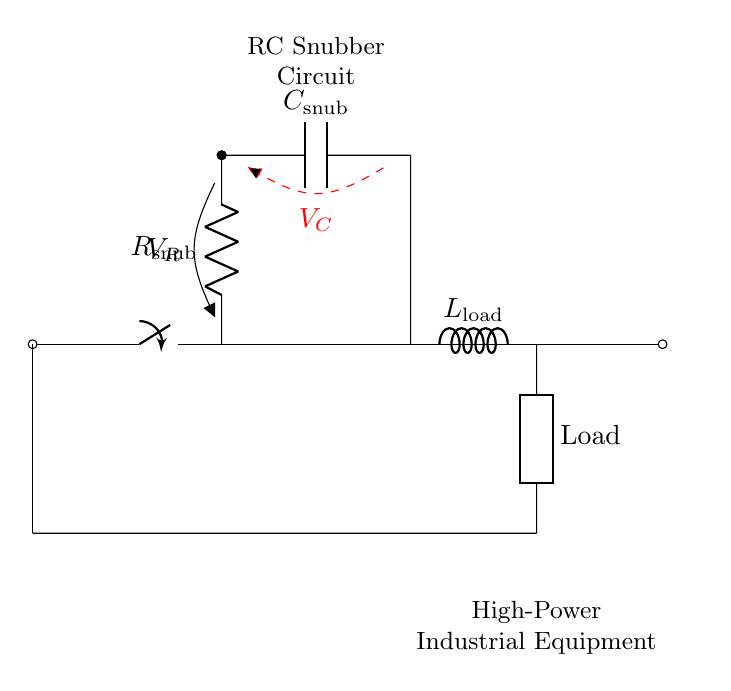What components are present in this circuit? The circuit contains a resistor, capacitor, inductor, switch, and a generic load. These components are visualized in distinct sections of the diagram indicating their roles.
Answer: resistor, capacitor, inductor, switch, load What does the switch control in this circuit? The switch controls the connection between the main power line and the other components of the circuit. When closed, it allows current to flow through the circuit, including the RC snubber.
Answer: power connection What is the purpose of the RC snubber circuit? The RC snubber circuit is designed to protect the high-power equipment from voltage spikes and transients by providing a controlled path for excess energy. This reduces the risk of damage to sensitive components.
Answer: voltage spike protection What is the voltage across the capacitor labeled as? The voltage across the capacitor is labeled as V_C, which indicates the voltage drop or potential difference observed across the capacitor in the snubber circuit.
Answer: V_C How is the load connected in relation to the snubber circuit? The load is connected in series with the inductor after the snubber circuit. This placement means that the load experiences the current after the RC snubber has mitigated any transient effects.
Answer: in series What happens to the voltage and current when the switch is closed? When the switch is closed, the voltage from the power line is applied to the snubber circuit and load, allowing current to flow. This results in charging the capacitor while the resistor dissipates energy during transients.
Answer: current flows 